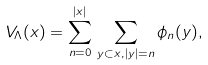<formula> <loc_0><loc_0><loc_500><loc_500>V _ { \Lambda } ( x ) = \sum _ { n = 0 } ^ { | x | } \, \sum _ { y \subset x , | y | = n } \phi _ { n } ( y ) ,</formula> 